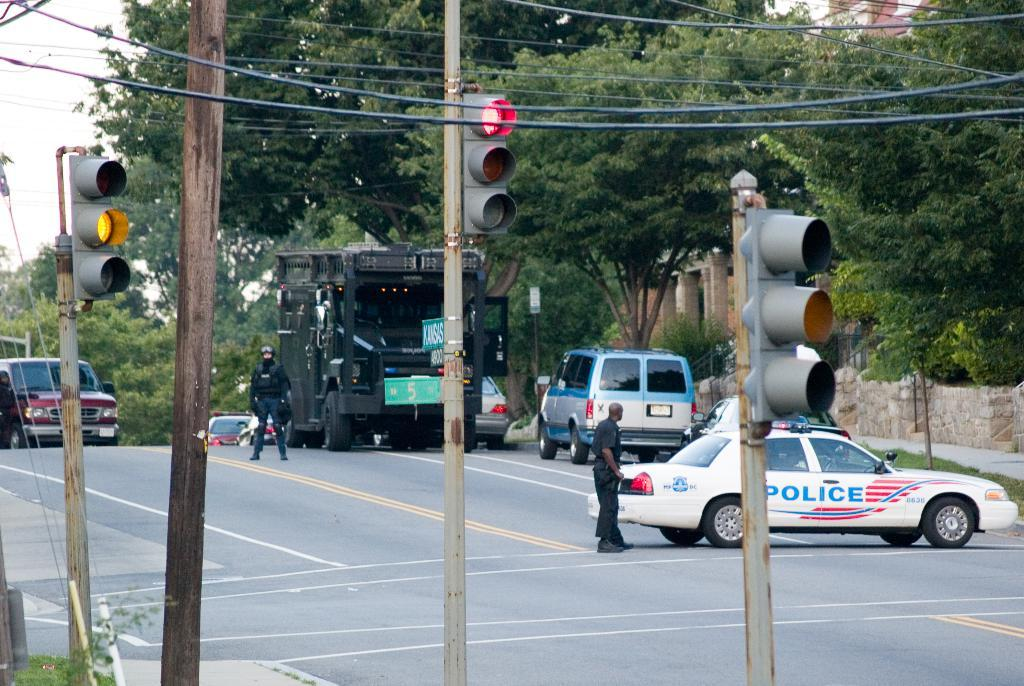<image>
Write a terse but informative summary of the picture. A police car blocks an intersection across a four lane highway. 